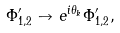Convert formula to latex. <formula><loc_0><loc_0><loc_500><loc_500>\Phi ^ { \prime } _ { 1 , 2 } \to e ^ { i \theta _ { k } } \Phi ^ { \prime } _ { 1 , 2 } ,</formula> 